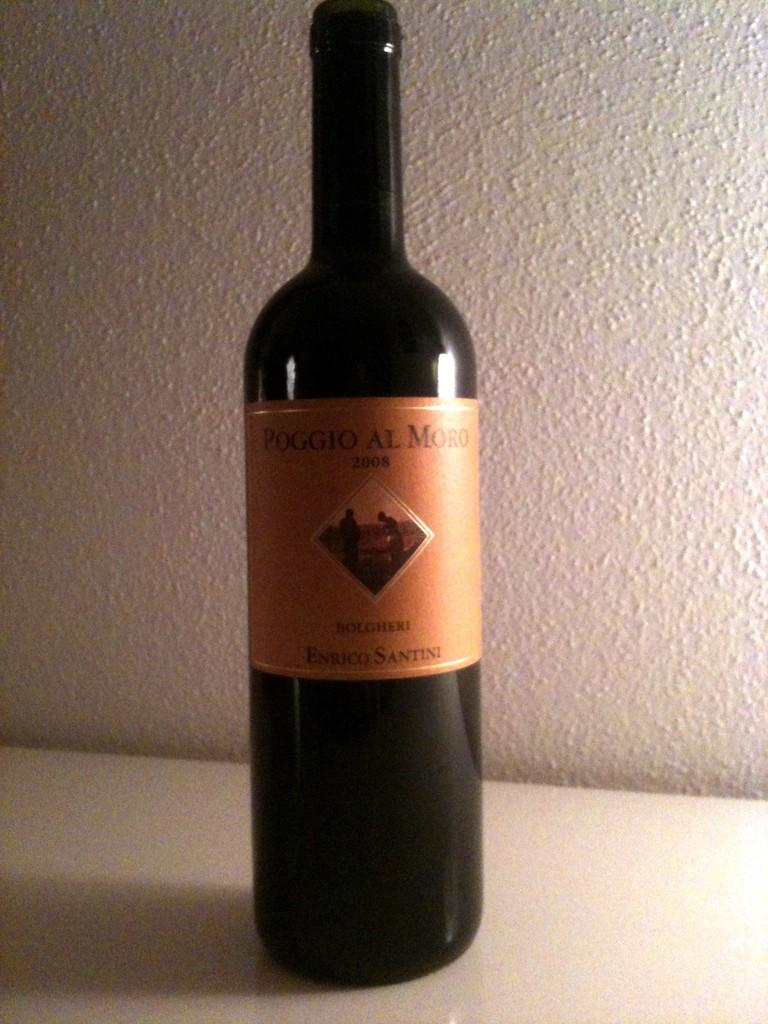<image>
Summarize the visual content of the image. A black bottle with the name Poggio Al Moro on its label. 